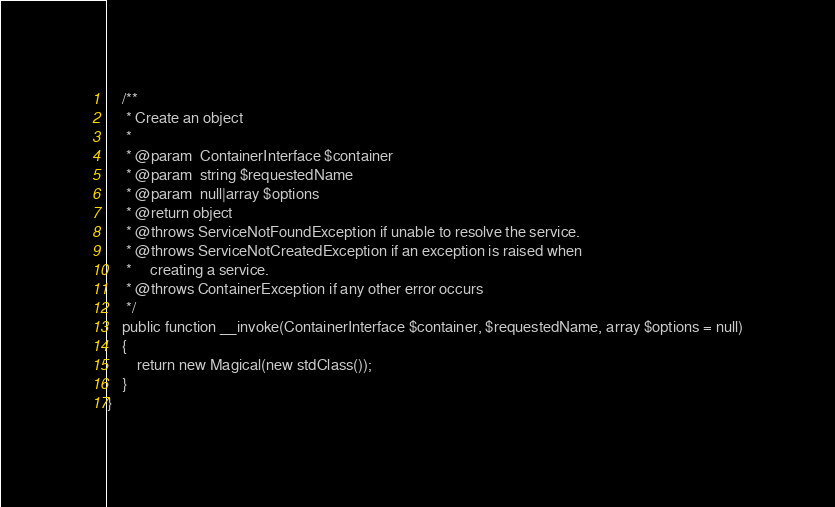Convert code to text. <code><loc_0><loc_0><loc_500><loc_500><_PHP_>    /**
     * Create an object
     *
     * @param  ContainerInterface $container
     * @param  string $requestedName
     * @param  null|array $options
     * @return object
     * @throws ServiceNotFoundException if unable to resolve the service.
     * @throws ServiceNotCreatedException if an exception is raised when
     *     creating a service.
     * @throws ContainerException if any other error occurs
     */
    public function __invoke(ContainerInterface $container, $requestedName, array $options = null)
    {
        return new Magical(new stdClass());
    }
}
</code> 